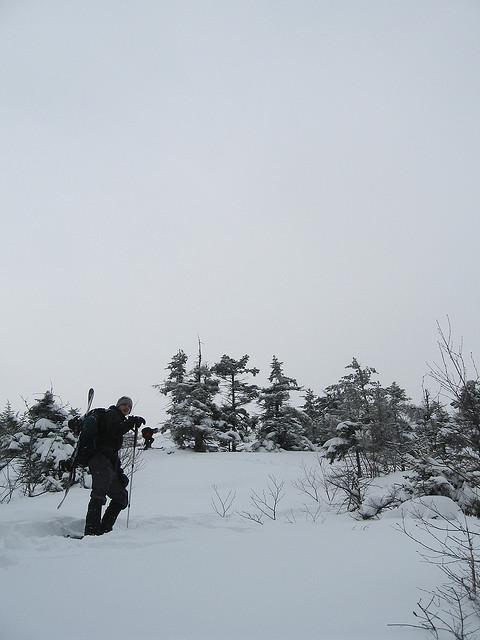What color is the coat?
Give a very brief answer. Black. Is there a hill in this picture?
Quick response, please. Yes. What sport is being played?
Keep it brief. Skiing. Could the season be autumn?
Quick response, please. No. Overcast or sunny?
Keep it brief. Overcast. Are fans watching?
Answer briefly. No. Is there any mountains in the picture?
Be succinct. No. Is the person going down a slope?
Be succinct. No. What is the person dragging?
Answer briefly. Skis. What type of Board is in this image?
Short answer required. Snowboard. Is it cold?
Keep it brief. Yes. Is the person wearing a helmet?
Short answer required. No. What color is the snow?
Write a very short answer. White. Is it snowing?
Be succinct. No. 